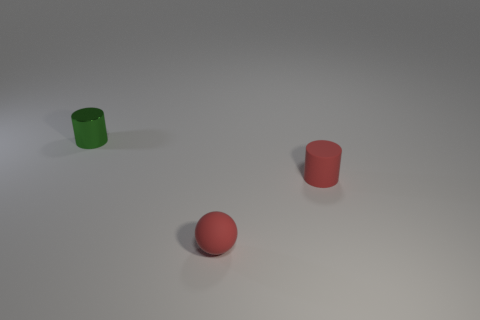Is the shape of the tiny red thing behind the small matte ball the same as the tiny green object behind the ball?
Make the answer very short. Yes. How many other things are the same material as the tiny green object?
Offer a very short reply. 0. What shape is the tiny red object that is the same material as the red cylinder?
Your response must be concise. Sphere. What shape is the thing that is the same color as the small rubber ball?
Offer a terse response. Cylinder. How many spheres are either small red objects or green metallic things?
Keep it short and to the point. 1. Is the number of small red cylinders on the right side of the small rubber sphere greater than the number of big green matte balls?
Offer a very short reply. Yes. There is a object that is the same material as the ball; what is its size?
Your answer should be compact. Small. Is there a small cylinder of the same color as the small matte sphere?
Your response must be concise. Yes. What number of things are red matte spheres or things behind the red matte ball?
Ensure brevity in your answer.  3. Is the number of matte cylinders greater than the number of big red shiny balls?
Give a very brief answer. Yes. 